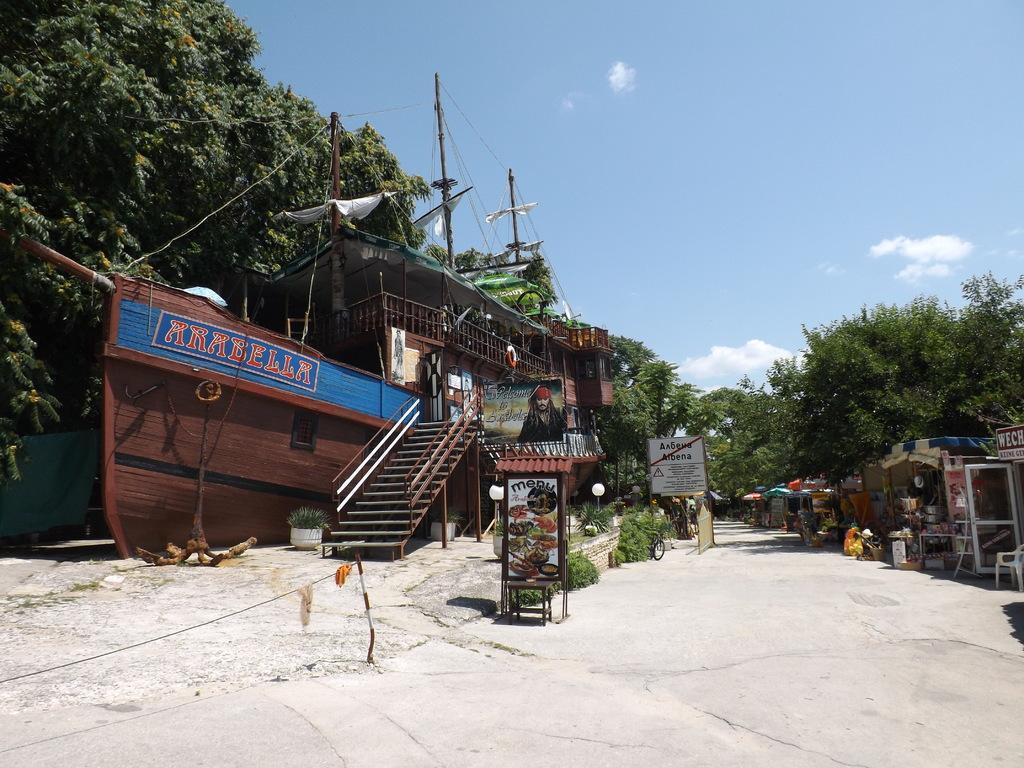Please provide a concise description of this image. In this image we can see the road, beside the road we can see some stalls, in the background of the image there are trees and some electric poles with cables on top of it. 